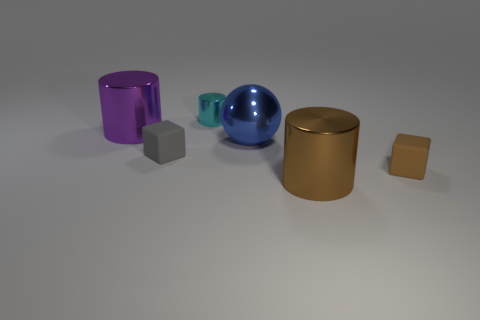There is a small thing that is in front of the tiny matte block that is left of the large ball; is there a tiny brown cube that is behind it?
Give a very brief answer. No. There is a blue metallic object that is the same size as the purple shiny object; what shape is it?
Your response must be concise. Sphere. Are there any small matte cubes that have the same color as the sphere?
Offer a terse response. No. Is the shape of the big brown thing the same as the brown rubber object?
Provide a short and direct response. No. How many tiny things are either brown cylinders or brown matte cubes?
Your answer should be compact. 1. What is the color of the large ball that is made of the same material as the brown cylinder?
Give a very brief answer. Blue. What number of tiny blue cylinders are the same material as the cyan cylinder?
Offer a terse response. 0. There is a metal object behind the large purple metallic cylinder; does it have the same size as the matte object to the left of the blue sphere?
Offer a very short reply. Yes. What is the material of the big cylinder that is in front of the large shiny cylinder that is behind the blue shiny thing?
Give a very brief answer. Metal. Is the number of small brown objects that are to the left of the tiny gray thing less than the number of brown metal cylinders that are behind the cyan object?
Keep it short and to the point. No. 